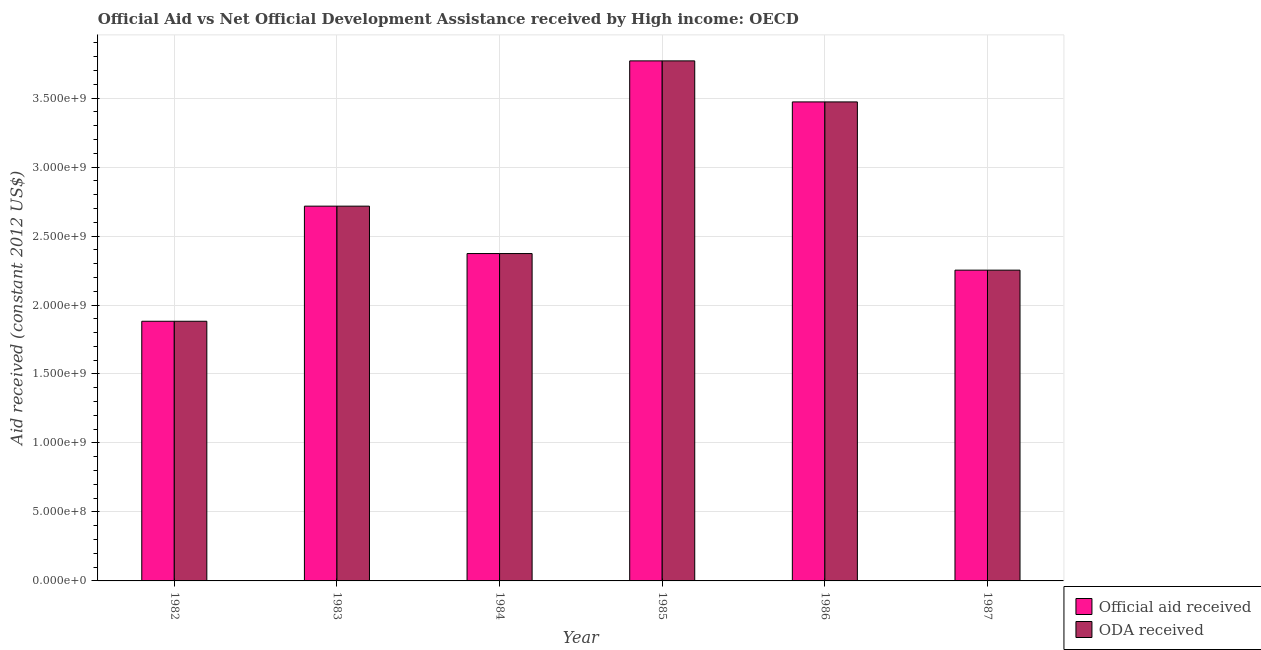How many different coloured bars are there?
Provide a short and direct response. 2. How many groups of bars are there?
Offer a terse response. 6. What is the label of the 1st group of bars from the left?
Keep it short and to the point. 1982. In how many cases, is the number of bars for a given year not equal to the number of legend labels?
Give a very brief answer. 0. What is the oda received in 1982?
Offer a very short reply. 1.88e+09. Across all years, what is the maximum oda received?
Your answer should be compact. 3.77e+09. Across all years, what is the minimum oda received?
Ensure brevity in your answer.  1.88e+09. What is the total official aid received in the graph?
Make the answer very short. 1.65e+1. What is the difference between the oda received in 1983 and that in 1985?
Provide a succinct answer. -1.05e+09. What is the difference between the official aid received in 1987 and the oda received in 1982?
Offer a very short reply. 3.70e+08. What is the average official aid received per year?
Make the answer very short. 2.74e+09. What is the ratio of the oda received in 1982 to that in 1986?
Your answer should be very brief. 0.54. What is the difference between the highest and the second highest oda received?
Provide a short and direct response. 2.97e+08. What is the difference between the highest and the lowest official aid received?
Give a very brief answer. 1.89e+09. In how many years, is the oda received greater than the average oda received taken over all years?
Keep it short and to the point. 2. What does the 2nd bar from the left in 1982 represents?
Provide a short and direct response. ODA received. What does the 2nd bar from the right in 1985 represents?
Your answer should be compact. Official aid received. Are all the bars in the graph horizontal?
Offer a terse response. No. Are the values on the major ticks of Y-axis written in scientific E-notation?
Your answer should be compact. Yes. Where does the legend appear in the graph?
Make the answer very short. Bottom right. How many legend labels are there?
Provide a succinct answer. 2. How are the legend labels stacked?
Your answer should be very brief. Vertical. What is the title of the graph?
Provide a short and direct response. Official Aid vs Net Official Development Assistance received by High income: OECD . Does "Goods and services" appear as one of the legend labels in the graph?
Ensure brevity in your answer.  No. What is the label or title of the Y-axis?
Your answer should be compact. Aid received (constant 2012 US$). What is the Aid received (constant 2012 US$) in Official aid received in 1982?
Your answer should be very brief. 1.88e+09. What is the Aid received (constant 2012 US$) in ODA received in 1982?
Make the answer very short. 1.88e+09. What is the Aid received (constant 2012 US$) in Official aid received in 1983?
Offer a terse response. 2.72e+09. What is the Aid received (constant 2012 US$) of ODA received in 1983?
Provide a short and direct response. 2.72e+09. What is the Aid received (constant 2012 US$) in Official aid received in 1984?
Offer a terse response. 2.37e+09. What is the Aid received (constant 2012 US$) of ODA received in 1984?
Make the answer very short. 2.37e+09. What is the Aid received (constant 2012 US$) of Official aid received in 1985?
Your answer should be very brief. 3.77e+09. What is the Aid received (constant 2012 US$) of ODA received in 1985?
Give a very brief answer. 3.77e+09. What is the Aid received (constant 2012 US$) in Official aid received in 1986?
Ensure brevity in your answer.  3.47e+09. What is the Aid received (constant 2012 US$) of ODA received in 1986?
Keep it short and to the point. 3.47e+09. What is the Aid received (constant 2012 US$) in Official aid received in 1987?
Your response must be concise. 2.25e+09. What is the Aid received (constant 2012 US$) in ODA received in 1987?
Your answer should be very brief. 2.25e+09. Across all years, what is the maximum Aid received (constant 2012 US$) in Official aid received?
Your response must be concise. 3.77e+09. Across all years, what is the maximum Aid received (constant 2012 US$) of ODA received?
Offer a terse response. 3.77e+09. Across all years, what is the minimum Aid received (constant 2012 US$) of Official aid received?
Keep it short and to the point. 1.88e+09. Across all years, what is the minimum Aid received (constant 2012 US$) of ODA received?
Your answer should be compact. 1.88e+09. What is the total Aid received (constant 2012 US$) in Official aid received in the graph?
Your answer should be compact. 1.65e+1. What is the total Aid received (constant 2012 US$) of ODA received in the graph?
Make the answer very short. 1.65e+1. What is the difference between the Aid received (constant 2012 US$) of Official aid received in 1982 and that in 1983?
Make the answer very short. -8.34e+08. What is the difference between the Aid received (constant 2012 US$) in ODA received in 1982 and that in 1983?
Provide a succinct answer. -8.34e+08. What is the difference between the Aid received (constant 2012 US$) in Official aid received in 1982 and that in 1984?
Provide a succinct answer. -4.91e+08. What is the difference between the Aid received (constant 2012 US$) in ODA received in 1982 and that in 1984?
Your answer should be compact. -4.91e+08. What is the difference between the Aid received (constant 2012 US$) of Official aid received in 1982 and that in 1985?
Your answer should be very brief. -1.89e+09. What is the difference between the Aid received (constant 2012 US$) of ODA received in 1982 and that in 1985?
Keep it short and to the point. -1.89e+09. What is the difference between the Aid received (constant 2012 US$) in Official aid received in 1982 and that in 1986?
Your response must be concise. -1.59e+09. What is the difference between the Aid received (constant 2012 US$) of ODA received in 1982 and that in 1986?
Your answer should be very brief. -1.59e+09. What is the difference between the Aid received (constant 2012 US$) of Official aid received in 1982 and that in 1987?
Offer a very short reply. -3.70e+08. What is the difference between the Aid received (constant 2012 US$) in ODA received in 1982 and that in 1987?
Make the answer very short. -3.70e+08. What is the difference between the Aid received (constant 2012 US$) in Official aid received in 1983 and that in 1984?
Give a very brief answer. 3.44e+08. What is the difference between the Aid received (constant 2012 US$) of ODA received in 1983 and that in 1984?
Your answer should be very brief. 3.44e+08. What is the difference between the Aid received (constant 2012 US$) of Official aid received in 1983 and that in 1985?
Offer a terse response. -1.05e+09. What is the difference between the Aid received (constant 2012 US$) of ODA received in 1983 and that in 1985?
Your response must be concise. -1.05e+09. What is the difference between the Aid received (constant 2012 US$) in Official aid received in 1983 and that in 1986?
Offer a very short reply. -7.56e+08. What is the difference between the Aid received (constant 2012 US$) of ODA received in 1983 and that in 1986?
Offer a terse response. -7.56e+08. What is the difference between the Aid received (constant 2012 US$) in Official aid received in 1983 and that in 1987?
Offer a very short reply. 4.64e+08. What is the difference between the Aid received (constant 2012 US$) of ODA received in 1983 and that in 1987?
Give a very brief answer. 4.64e+08. What is the difference between the Aid received (constant 2012 US$) of Official aid received in 1984 and that in 1985?
Offer a very short reply. -1.40e+09. What is the difference between the Aid received (constant 2012 US$) of ODA received in 1984 and that in 1985?
Make the answer very short. -1.40e+09. What is the difference between the Aid received (constant 2012 US$) in Official aid received in 1984 and that in 1986?
Your answer should be compact. -1.10e+09. What is the difference between the Aid received (constant 2012 US$) in ODA received in 1984 and that in 1986?
Give a very brief answer. -1.10e+09. What is the difference between the Aid received (constant 2012 US$) of Official aid received in 1984 and that in 1987?
Provide a succinct answer. 1.20e+08. What is the difference between the Aid received (constant 2012 US$) in ODA received in 1984 and that in 1987?
Keep it short and to the point. 1.20e+08. What is the difference between the Aid received (constant 2012 US$) in Official aid received in 1985 and that in 1986?
Provide a short and direct response. 2.97e+08. What is the difference between the Aid received (constant 2012 US$) in ODA received in 1985 and that in 1986?
Give a very brief answer. 2.97e+08. What is the difference between the Aid received (constant 2012 US$) of Official aid received in 1985 and that in 1987?
Provide a short and direct response. 1.52e+09. What is the difference between the Aid received (constant 2012 US$) of ODA received in 1985 and that in 1987?
Provide a short and direct response. 1.52e+09. What is the difference between the Aid received (constant 2012 US$) in Official aid received in 1986 and that in 1987?
Offer a terse response. 1.22e+09. What is the difference between the Aid received (constant 2012 US$) in ODA received in 1986 and that in 1987?
Offer a terse response. 1.22e+09. What is the difference between the Aid received (constant 2012 US$) in Official aid received in 1982 and the Aid received (constant 2012 US$) in ODA received in 1983?
Your response must be concise. -8.34e+08. What is the difference between the Aid received (constant 2012 US$) in Official aid received in 1982 and the Aid received (constant 2012 US$) in ODA received in 1984?
Your answer should be compact. -4.91e+08. What is the difference between the Aid received (constant 2012 US$) in Official aid received in 1982 and the Aid received (constant 2012 US$) in ODA received in 1985?
Keep it short and to the point. -1.89e+09. What is the difference between the Aid received (constant 2012 US$) in Official aid received in 1982 and the Aid received (constant 2012 US$) in ODA received in 1986?
Keep it short and to the point. -1.59e+09. What is the difference between the Aid received (constant 2012 US$) in Official aid received in 1982 and the Aid received (constant 2012 US$) in ODA received in 1987?
Your answer should be compact. -3.70e+08. What is the difference between the Aid received (constant 2012 US$) in Official aid received in 1983 and the Aid received (constant 2012 US$) in ODA received in 1984?
Provide a short and direct response. 3.44e+08. What is the difference between the Aid received (constant 2012 US$) of Official aid received in 1983 and the Aid received (constant 2012 US$) of ODA received in 1985?
Make the answer very short. -1.05e+09. What is the difference between the Aid received (constant 2012 US$) of Official aid received in 1983 and the Aid received (constant 2012 US$) of ODA received in 1986?
Your answer should be very brief. -7.56e+08. What is the difference between the Aid received (constant 2012 US$) of Official aid received in 1983 and the Aid received (constant 2012 US$) of ODA received in 1987?
Offer a terse response. 4.64e+08. What is the difference between the Aid received (constant 2012 US$) in Official aid received in 1984 and the Aid received (constant 2012 US$) in ODA received in 1985?
Give a very brief answer. -1.40e+09. What is the difference between the Aid received (constant 2012 US$) in Official aid received in 1984 and the Aid received (constant 2012 US$) in ODA received in 1986?
Provide a short and direct response. -1.10e+09. What is the difference between the Aid received (constant 2012 US$) of Official aid received in 1984 and the Aid received (constant 2012 US$) of ODA received in 1987?
Your answer should be compact. 1.20e+08. What is the difference between the Aid received (constant 2012 US$) of Official aid received in 1985 and the Aid received (constant 2012 US$) of ODA received in 1986?
Provide a short and direct response. 2.97e+08. What is the difference between the Aid received (constant 2012 US$) in Official aid received in 1985 and the Aid received (constant 2012 US$) in ODA received in 1987?
Keep it short and to the point. 1.52e+09. What is the difference between the Aid received (constant 2012 US$) in Official aid received in 1986 and the Aid received (constant 2012 US$) in ODA received in 1987?
Your answer should be very brief. 1.22e+09. What is the average Aid received (constant 2012 US$) of Official aid received per year?
Offer a terse response. 2.74e+09. What is the average Aid received (constant 2012 US$) of ODA received per year?
Your answer should be compact. 2.74e+09. In the year 1982, what is the difference between the Aid received (constant 2012 US$) in Official aid received and Aid received (constant 2012 US$) in ODA received?
Offer a very short reply. 0. What is the ratio of the Aid received (constant 2012 US$) of Official aid received in 1982 to that in 1983?
Offer a very short reply. 0.69. What is the ratio of the Aid received (constant 2012 US$) of ODA received in 1982 to that in 1983?
Provide a short and direct response. 0.69. What is the ratio of the Aid received (constant 2012 US$) of Official aid received in 1982 to that in 1984?
Make the answer very short. 0.79. What is the ratio of the Aid received (constant 2012 US$) in ODA received in 1982 to that in 1984?
Offer a terse response. 0.79. What is the ratio of the Aid received (constant 2012 US$) of Official aid received in 1982 to that in 1985?
Give a very brief answer. 0.5. What is the ratio of the Aid received (constant 2012 US$) of ODA received in 1982 to that in 1985?
Offer a terse response. 0.5. What is the ratio of the Aid received (constant 2012 US$) in Official aid received in 1982 to that in 1986?
Make the answer very short. 0.54. What is the ratio of the Aid received (constant 2012 US$) in ODA received in 1982 to that in 1986?
Your answer should be compact. 0.54. What is the ratio of the Aid received (constant 2012 US$) of Official aid received in 1982 to that in 1987?
Give a very brief answer. 0.84. What is the ratio of the Aid received (constant 2012 US$) of ODA received in 1982 to that in 1987?
Keep it short and to the point. 0.84. What is the ratio of the Aid received (constant 2012 US$) of Official aid received in 1983 to that in 1984?
Your answer should be very brief. 1.14. What is the ratio of the Aid received (constant 2012 US$) of ODA received in 1983 to that in 1984?
Provide a short and direct response. 1.14. What is the ratio of the Aid received (constant 2012 US$) in Official aid received in 1983 to that in 1985?
Give a very brief answer. 0.72. What is the ratio of the Aid received (constant 2012 US$) of ODA received in 1983 to that in 1985?
Your response must be concise. 0.72. What is the ratio of the Aid received (constant 2012 US$) in Official aid received in 1983 to that in 1986?
Ensure brevity in your answer.  0.78. What is the ratio of the Aid received (constant 2012 US$) of ODA received in 1983 to that in 1986?
Ensure brevity in your answer.  0.78. What is the ratio of the Aid received (constant 2012 US$) of Official aid received in 1983 to that in 1987?
Provide a succinct answer. 1.21. What is the ratio of the Aid received (constant 2012 US$) of ODA received in 1983 to that in 1987?
Provide a succinct answer. 1.21. What is the ratio of the Aid received (constant 2012 US$) in Official aid received in 1984 to that in 1985?
Your response must be concise. 0.63. What is the ratio of the Aid received (constant 2012 US$) of ODA received in 1984 to that in 1985?
Make the answer very short. 0.63. What is the ratio of the Aid received (constant 2012 US$) in Official aid received in 1984 to that in 1986?
Make the answer very short. 0.68. What is the ratio of the Aid received (constant 2012 US$) of ODA received in 1984 to that in 1986?
Give a very brief answer. 0.68. What is the ratio of the Aid received (constant 2012 US$) of Official aid received in 1984 to that in 1987?
Keep it short and to the point. 1.05. What is the ratio of the Aid received (constant 2012 US$) of ODA received in 1984 to that in 1987?
Offer a very short reply. 1.05. What is the ratio of the Aid received (constant 2012 US$) of Official aid received in 1985 to that in 1986?
Provide a succinct answer. 1.09. What is the ratio of the Aid received (constant 2012 US$) of ODA received in 1985 to that in 1986?
Make the answer very short. 1.09. What is the ratio of the Aid received (constant 2012 US$) of Official aid received in 1985 to that in 1987?
Provide a succinct answer. 1.67. What is the ratio of the Aid received (constant 2012 US$) of ODA received in 1985 to that in 1987?
Your answer should be very brief. 1.67. What is the ratio of the Aid received (constant 2012 US$) of Official aid received in 1986 to that in 1987?
Ensure brevity in your answer.  1.54. What is the ratio of the Aid received (constant 2012 US$) in ODA received in 1986 to that in 1987?
Make the answer very short. 1.54. What is the difference between the highest and the second highest Aid received (constant 2012 US$) of Official aid received?
Provide a short and direct response. 2.97e+08. What is the difference between the highest and the second highest Aid received (constant 2012 US$) of ODA received?
Keep it short and to the point. 2.97e+08. What is the difference between the highest and the lowest Aid received (constant 2012 US$) in Official aid received?
Make the answer very short. 1.89e+09. What is the difference between the highest and the lowest Aid received (constant 2012 US$) in ODA received?
Give a very brief answer. 1.89e+09. 